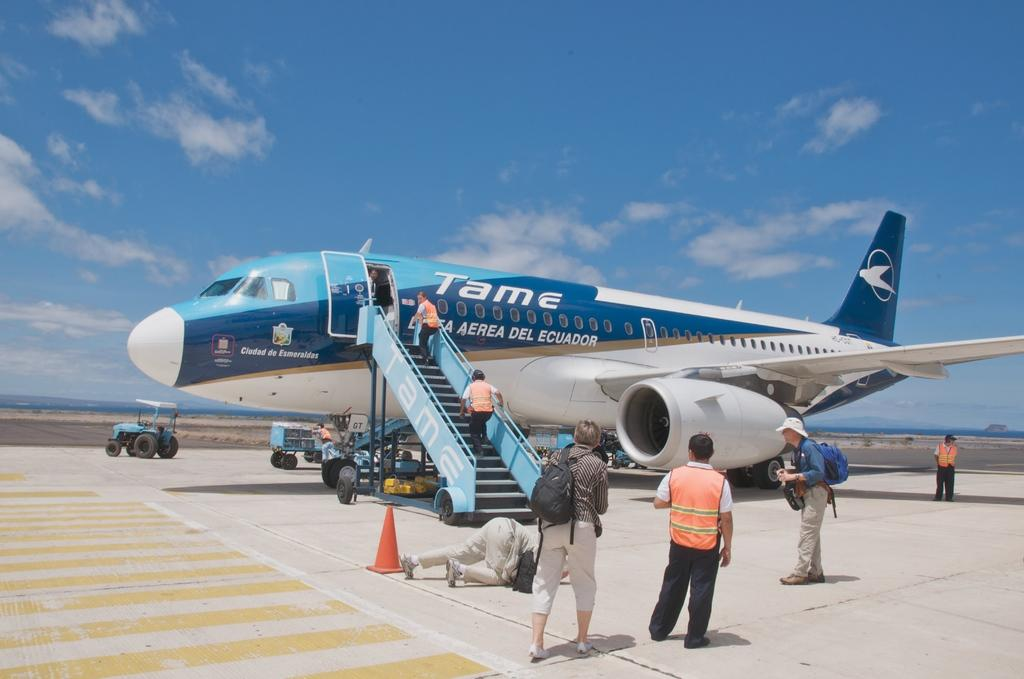<image>
Share a concise interpretation of the image provided. The airline is from the country of Ecuador 